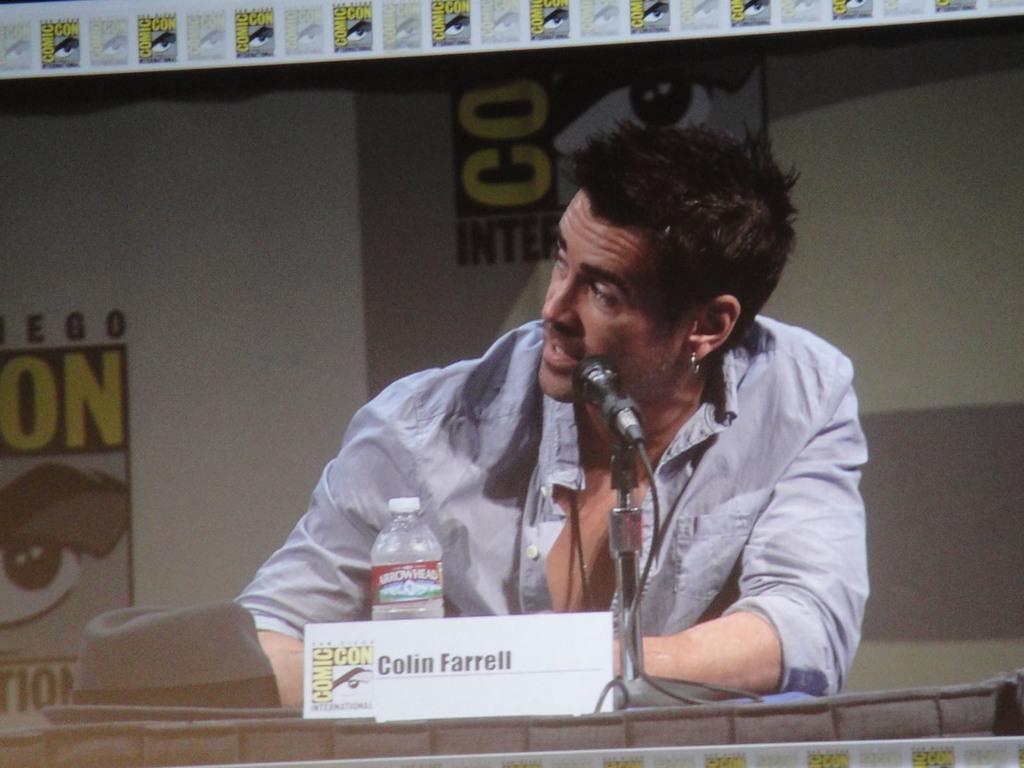Can you describe this image briefly? In this image, we can see a person and there is a bottle, hat, board and a mic are on the podium and in the background, there is a board. 